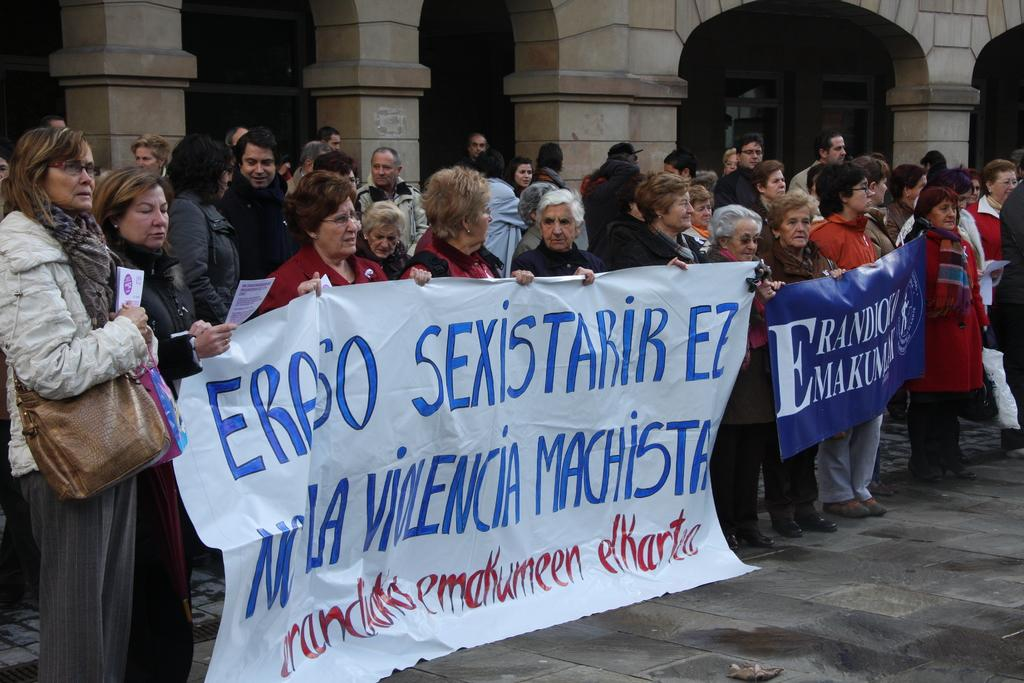What is happening in the image involving a group of people? The people in the image are protesting against an issue. What are the people holding in their hands? The people are holding banners in their hands. What can be seen in the background of the image? There is a building in the background of the image. What type of pipe is being used to create friction among the protesters in the image? There is no pipe or friction present among the protesters in the image; they are holding banners and protesting against an issue. 